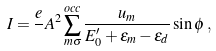Convert formula to latex. <formula><loc_0><loc_0><loc_500><loc_500>I = \frac { e } { } A ^ { 2 } \sum _ { m \sigma } ^ { o c c } \frac { u _ { m } } { E _ { 0 } ^ { \prime } + \varepsilon _ { m } - \varepsilon _ { d } } \sin { \phi } \, ,</formula> 